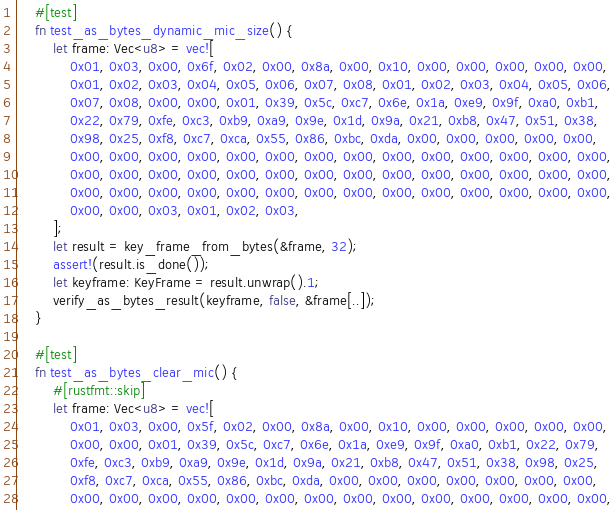<code> <loc_0><loc_0><loc_500><loc_500><_Rust_>    #[test]
    fn test_as_bytes_dynamic_mic_size() {
        let frame: Vec<u8> = vec![
            0x01, 0x03, 0x00, 0x6f, 0x02, 0x00, 0x8a, 0x00, 0x10, 0x00, 0x00, 0x00, 0x00, 0x00,
            0x01, 0x02, 0x03, 0x04, 0x05, 0x06, 0x07, 0x08, 0x01, 0x02, 0x03, 0x04, 0x05, 0x06,
            0x07, 0x08, 0x00, 0x00, 0x01, 0x39, 0x5c, 0xc7, 0x6e, 0x1a, 0xe9, 0x9f, 0xa0, 0xb1,
            0x22, 0x79, 0xfe, 0xc3, 0xb9, 0xa9, 0x9e, 0x1d, 0x9a, 0x21, 0xb8, 0x47, 0x51, 0x38,
            0x98, 0x25, 0xf8, 0xc7, 0xca, 0x55, 0x86, 0xbc, 0xda, 0x00, 0x00, 0x00, 0x00, 0x00,
            0x00, 0x00, 0x00, 0x00, 0x00, 0x00, 0x00, 0x00, 0x00, 0x00, 0x00, 0x00, 0x00, 0x00,
            0x00, 0x00, 0x00, 0x00, 0x00, 0x00, 0x00, 0x00, 0x00, 0x00, 0x00, 0x00, 0x00, 0x00,
            0x00, 0x00, 0x00, 0x00, 0x00, 0x00, 0x00, 0x00, 0x00, 0x00, 0x00, 0x00, 0x00, 0x00,
            0x00, 0x00, 0x03, 0x01, 0x02, 0x03,
        ];
        let result = key_frame_from_bytes(&frame, 32);
        assert!(result.is_done());
        let keyframe: KeyFrame = result.unwrap().1;
        verify_as_bytes_result(keyframe, false, &frame[..]);
    }

    #[test]
    fn test_as_bytes_clear_mic() {
        #[rustfmt::skip]
        let frame: Vec<u8> = vec![
            0x01, 0x03, 0x00, 0x5f, 0x02, 0x00, 0x8a, 0x00, 0x10, 0x00, 0x00, 0x00, 0x00, 0x00,
            0x00, 0x00, 0x01, 0x39, 0x5c, 0xc7, 0x6e, 0x1a, 0xe9, 0x9f, 0xa0, 0xb1, 0x22, 0x79,
            0xfe, 0xc3, 0xb9, 0xa9, 0x9e, 0x1d, 0x9a, 0x21, 0xb8, 0x47, 0x51, 0x38, 0x98, 0x25,
            0xf8, 0xc7, 0xca, 0x55, 0x86, 0xbc, 0xda, 0x00, 0x00, 0x00, 0x00, 0x00, 0x00, 0x00,
            0x00, 0x00, 0x00, 0x00, 0x00, 0x00, 0x00, 0x00, 0x00, 0x00, 0x00, 0x00, 0x00, 0x00,</code> 